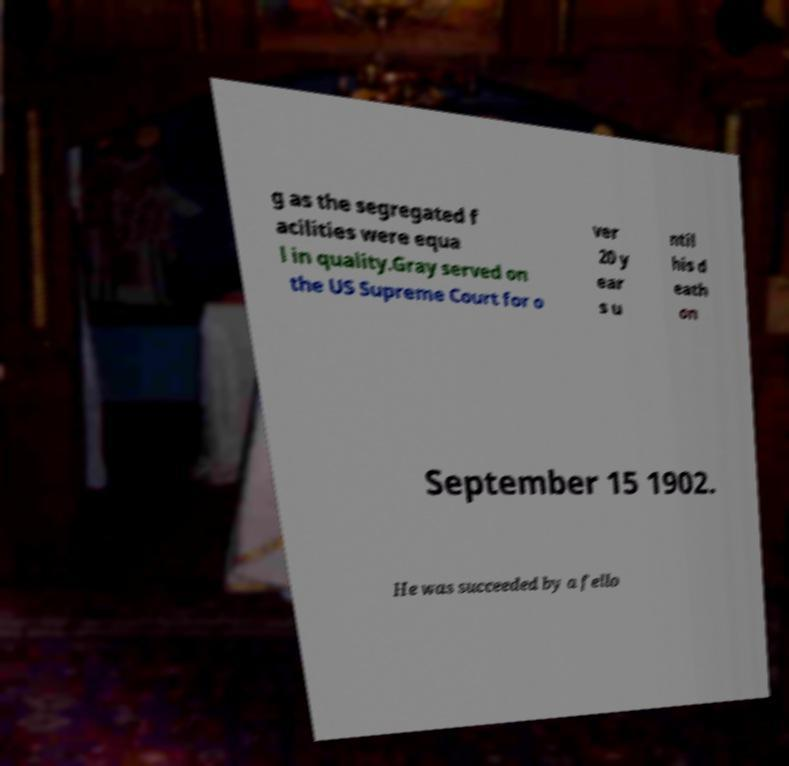What messages or text are displayed in this image? I need them in a readable, typed format. g as the segregated f acilities were equa l in quality.Gray served on the US Supreme Court for o ver 20 y ear s u ntil his d eath on September 15 1902. He was succeeded by a fello 